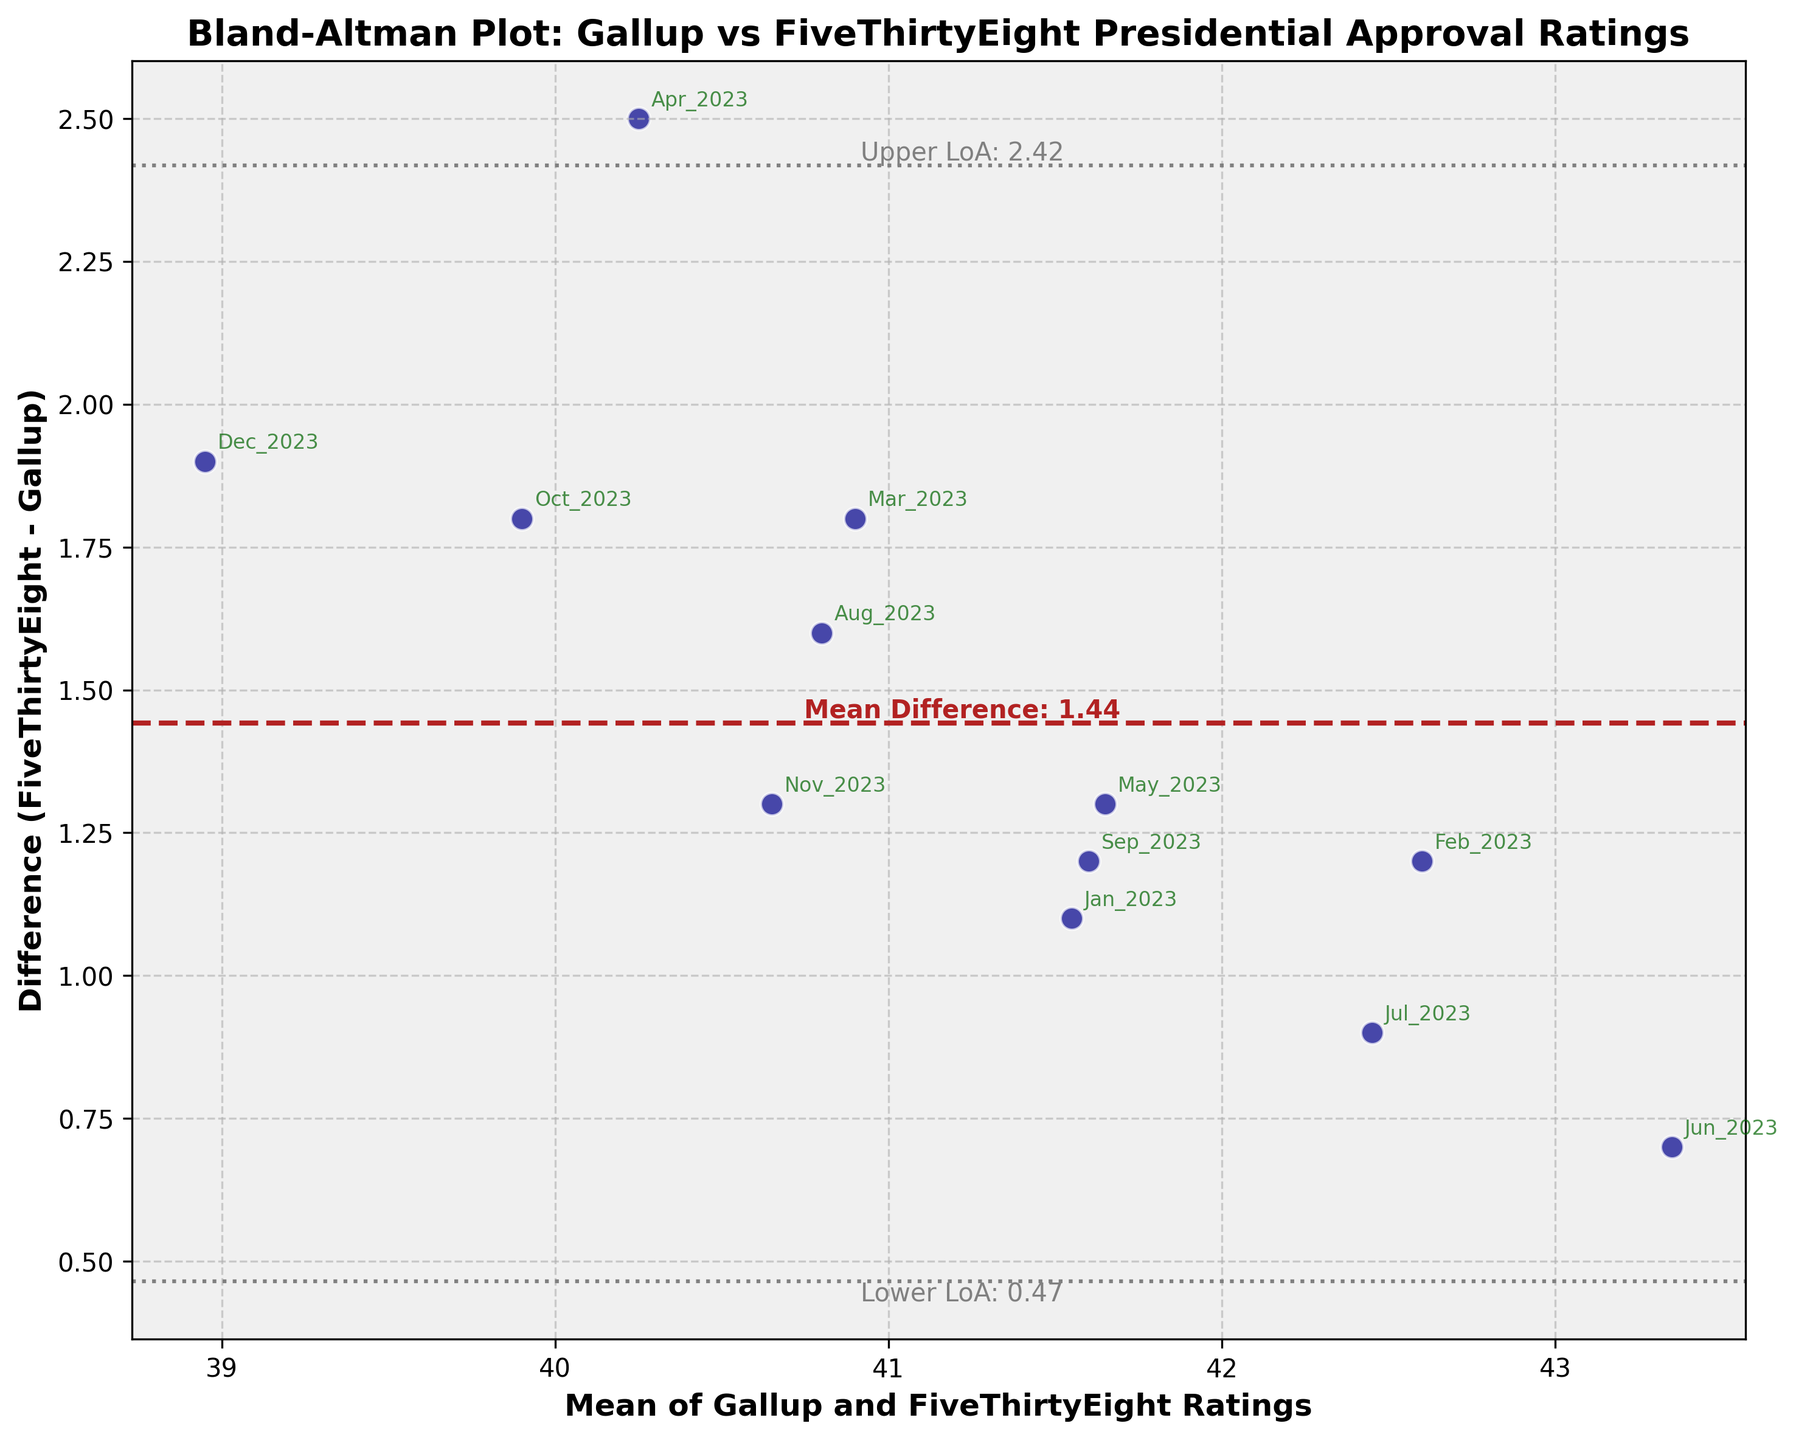what is the title of the plot? The title can be found at the top of the plot. It reads "Bland-Altman Plot: Gallup vs FiveThirtyEight Presidential Approval Ratings".
Answer: Bland-Altman Plot: Gallup vs FiveThirtyEight Presidential Approval Ratings How many data points are there in the plot? There are data points for each month from January to December 2023. Counting these, we get 12 data points in total.
Answer: 12 What is the mean difference between FiveThirtyEight and Gallup ratings, and how is it indicated on the plot? The mean difference is marked by a horizontal dashed line and labeled with text near the line. This value is shown as "Mean Difference: 1.02".
Answer: 1.02 What is the range of the Limits of Agreement (LoA), and how are they represented on the plot? The Limits of Agreement are shown as two horizontal dotted lines. They are labeled as "Lower LoA" and "Upper LoA". The text labels show these values as -0.60 and 2.64, respectively.
Answer: -0.60 to 2.64 How do the majority of the data points relate to the mean difference line? By observing the plot, most data points appear to be clustered close to the mean difference line, suggesting similarity between the two polling organizations' ratings. This shows that FiveThirtyEight ratings are generally close to Gallup ratings with a small positive difference.
Answer: Clustered close to the mean difference line Which months have the highest and lowest differences, and what are these differences? The annotations on the data points help identify the months. The largest positive difference occurs in June 2023, while the largest negative difference occurs in April 2023. The specific values from the plot show a difference of 0.7 in June and -0.6 in April.
Answer: June (0.7) and April (-0.6) Is there any visible trend or pattern in the scatter of differences across months? Observing the scatter plot, there does not appear to be a consistent upward or downward trend in the differences. The differences fluctuate around the mean difference line throughout the year.
Answer: No consistent trend What can be inferred about the consistency between Gallup and FiveThirtyEight ratings based on the Limits of Agreement? Since most data points fall within the Limits of Agreement, it indicates that the ratings from Gallup and FiveThirtyEight are generally consistent with each other, staying within a small range of difference for the most part.
Answer: High consistency 